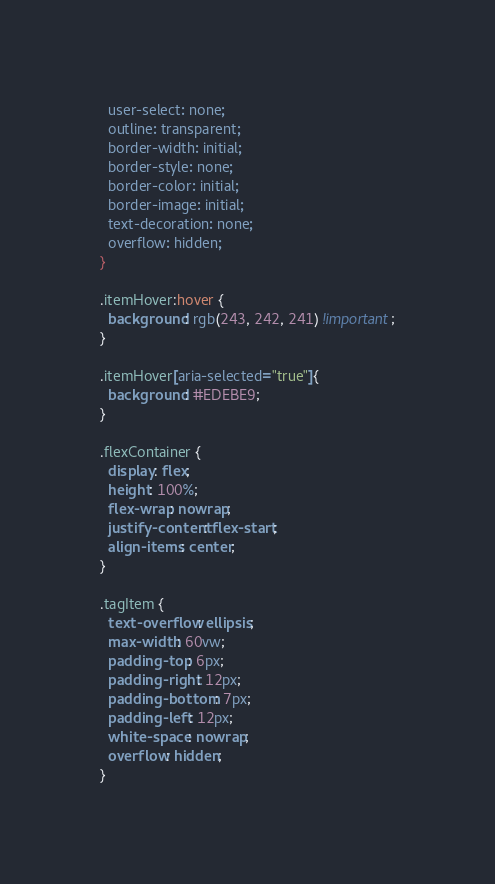<code> <loc_0><loc_0><loc_500><loc_500><_CSS_>  user-select: none;
  outline: transparent;
  border-width: initial;
  border-style: none;
  border-color: initial;
  border-image: initial;
  text-decoration: none;
  overflow: hidden;
}

.itemHover:hover {
  background: rgb(243, 242, 241) !important;
}

.itemHover[aria-selected="true"]{
  background: #EDEBE9;
}

.flexContainer {
  display: flex;
  height: 100%;
  flex-wrap: nowrap;
  justify-content: flex-start;
  align-items: center;
}

.tagItem {
  text-overflow: ellipsis;
  max-width: 60vw;
  padding-top: 6px;
  padding-right: 12px;
  padding-bottom: 7px;
  padding-left: 12px;
  white-space: nowrap;
  overflow: hidden;
}
</code> 